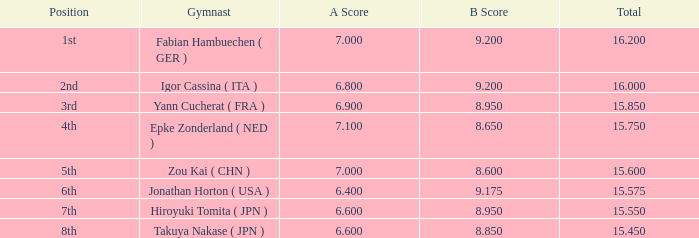What was the total rating that had a score higher than 7 and a b score smaller than 8.65? None. 